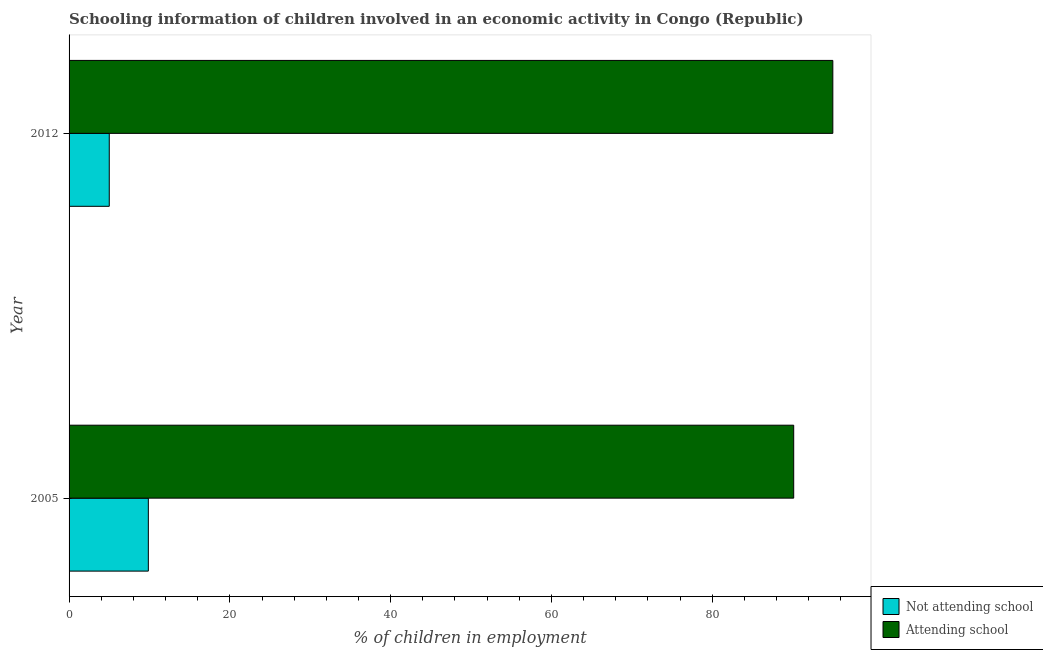How many different coloured bars are there?
Make the answer very short. 2. How many groups of bars are there?
Give a very brief answer. 2. Across all years, what is the maximum percentage of employed children who are not attending school?
Provide a succinct answer. 9.86. In which year was the percentage of employed children who are not attending school maximum?
Ensure brevity in your answer.  2005. In which year was the percentage of employed children who are attending school minimum?
Keep it short and to the point. 2005. What is the total percentage of employed children who are attending school in the graph?
Your answer should be compact. 185.13. What is the difference between the percentage of employed children who are not attending school in 2005 and that in 2012?
Offer a terse response. 4.86. What is the difference between the percentage of employed children who are not attending school in 2005 and the percentage of employed children who are attending school in 2012?
Provide a short and direct response. -85.14. What is the average percentage of employed children who are attending school per year?
Your response must be concise. 92.57. In the year 2005, what is the difference between the percentage of employed children who are attending school and percentage of employed children who are not attending school?
Make the answer very short. 80.28. In how many years, is the percentage of employed children who are not attending school greater than 76 %?
Offer a very short reply. 0. What is the ratio of the percentage of employed children who are attending school in 2005 to that in 2012?
Ensure brevity in your answer.  0.95. Is the percentage of employed children who are attending school in 2005 less than that in 2012?
Provide a succinct answer. Yes. What does the 1st bar from the top in 2012 represents?
Your answer should be compact. Attending school. What does the 2nd bar from the bottom in 2012 represents?
Offer a terse response. Attending school. How many years are there in the graph?
Your answer should be very brief. 2. Are the values on the major ticks of X-axis written in scientific E-notation?
Provide a short and direct response. No. Does the graph contain any zero values?
Offer a very short reply. No. Where does the legend appear in the graph?
Provide a short and direct response. Bottom right. How many legend labels are there?
Your response must be concise. 2. How are the legend labels stacked?
Your response must be concise. Vertical. What is the title of the graph?
Provide a succinct answer. Schooling information of children involved in an economic activity in Congo (Republic). What is the label or title of the X-axis?
Ensure brevity in your answer.  % of children in employment. What is the label or title of the Y-axis?
Provide a succinct answer. Year. What is the % of children in employment in Not attending school in 2005?
Ensure brevity in your answer.  9.86. What is the % of children in employment in Attending school in 2005?
Offer a very short reply. 90.14. What is the % of children in employment in Not attending school in 2012?
Offer a terse response. 5. What is the % of children in employment in Attending school in 2012?
Your response must be concise. 95. Across all years, what is the maximum % of children in employment of Not attending school?
Your answer should be compact. 9.86. Across all years, what is the maximum % of children in employment in Attending school?
Give a very brief answer. 95. Across all years, what is the minimum % of children in employment in Attending school?
Offer a terse response. 90.14. What is the total % of children in employment of Not attending school in the graph?
Your answer should be compact. 14.86. What is the total % of children in employment in Attending school in the graph?
Your answer should be very brief. 185.13. What is the difference between the % of children in employment of Not attending school in 2005 and that in 2012?
Provide a succinct answer. 4.86. What is the difference between the % of children in employment in Attending school in 2005 and that in 2012?
Keep it short and to the point. -4.87. What is the difference between the % of children in employment of Not attending school in 2005 and the % of children in employment of Attending school in 2012?
Give a very brief answer. -85.14. What is the average % of children in employment in Not attending school per year?
Your answer should be compact. 7.43. What is the average % of children in employment in Attending school per year?
Offer a very short reply. 92.57. In the year 2005, what is the difference between the % of children in employment in Not attending school and % of children in employment in Attending school?
Offer a very short reply. -80.28. In the year 2012, what is the difference between the % of children in employment in Not attending school and % of children in employment in Attending school?
Provide a short and direct response. -90. What is the ratio of the % of children in employment in Not attending school in 2005 to that in 2012?
Your response must be concise. 1.97. What is the ratio of the % of children in employment of Attending school in 2005 to that in 2012?
Keep it short and to the point. 0.95. What is the difference between the highest and the second highest % of children in employment of Not attending school?
Your response must be concise. 4.86. What is the difference between the highest and the second highest % of children in employment of Attending school?
Your answer should be very brief. 4.87. What is the difference between the highest and the lowest % of children in employment of Not attending school?
Offer a terse response. 4.86. What is the difference between the highest and the lowest % of children in employment in Attending school?
Provide a short and direct response. 4.87. 